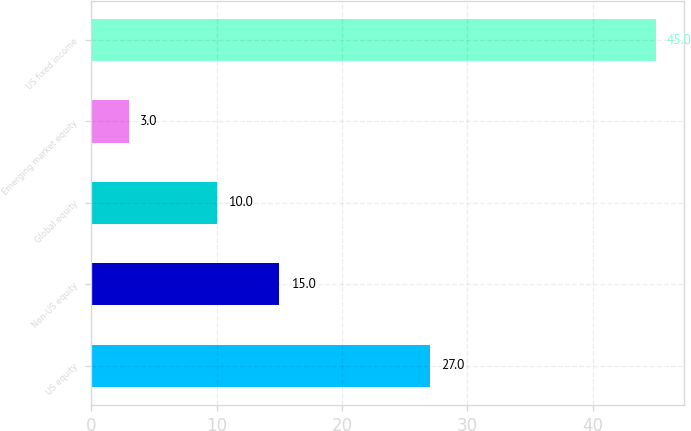<chart> <loc_0><loc_0><loc_500><loc_500><bar_chart><fcel>US equity<fcel>Non-US equity<fcel>Global equity<fcel>Emerging market equity<fcel>US fixed income<nl><fcel>27<fcel>15<fcel>10<fcel>3<fcel>45<nl></chart> 